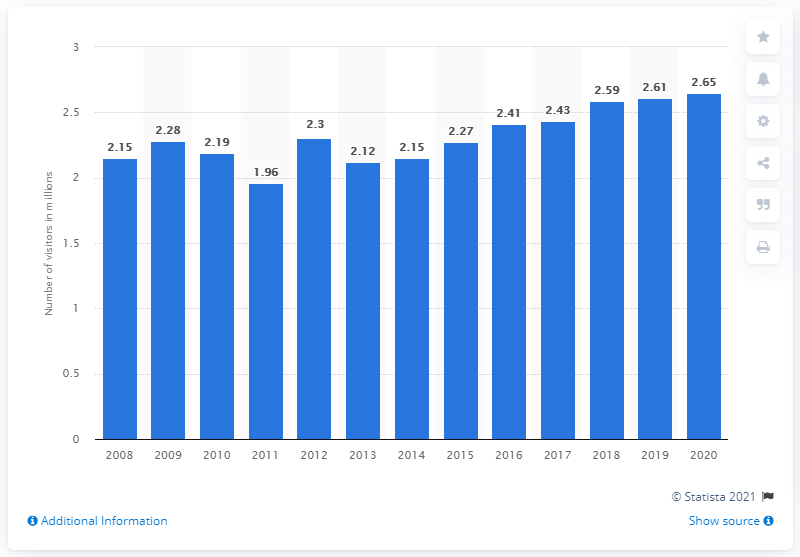Point out several critical features in this image. In 2020, there were 2.65 million visitors to Cape Hatteras National Seashore. 